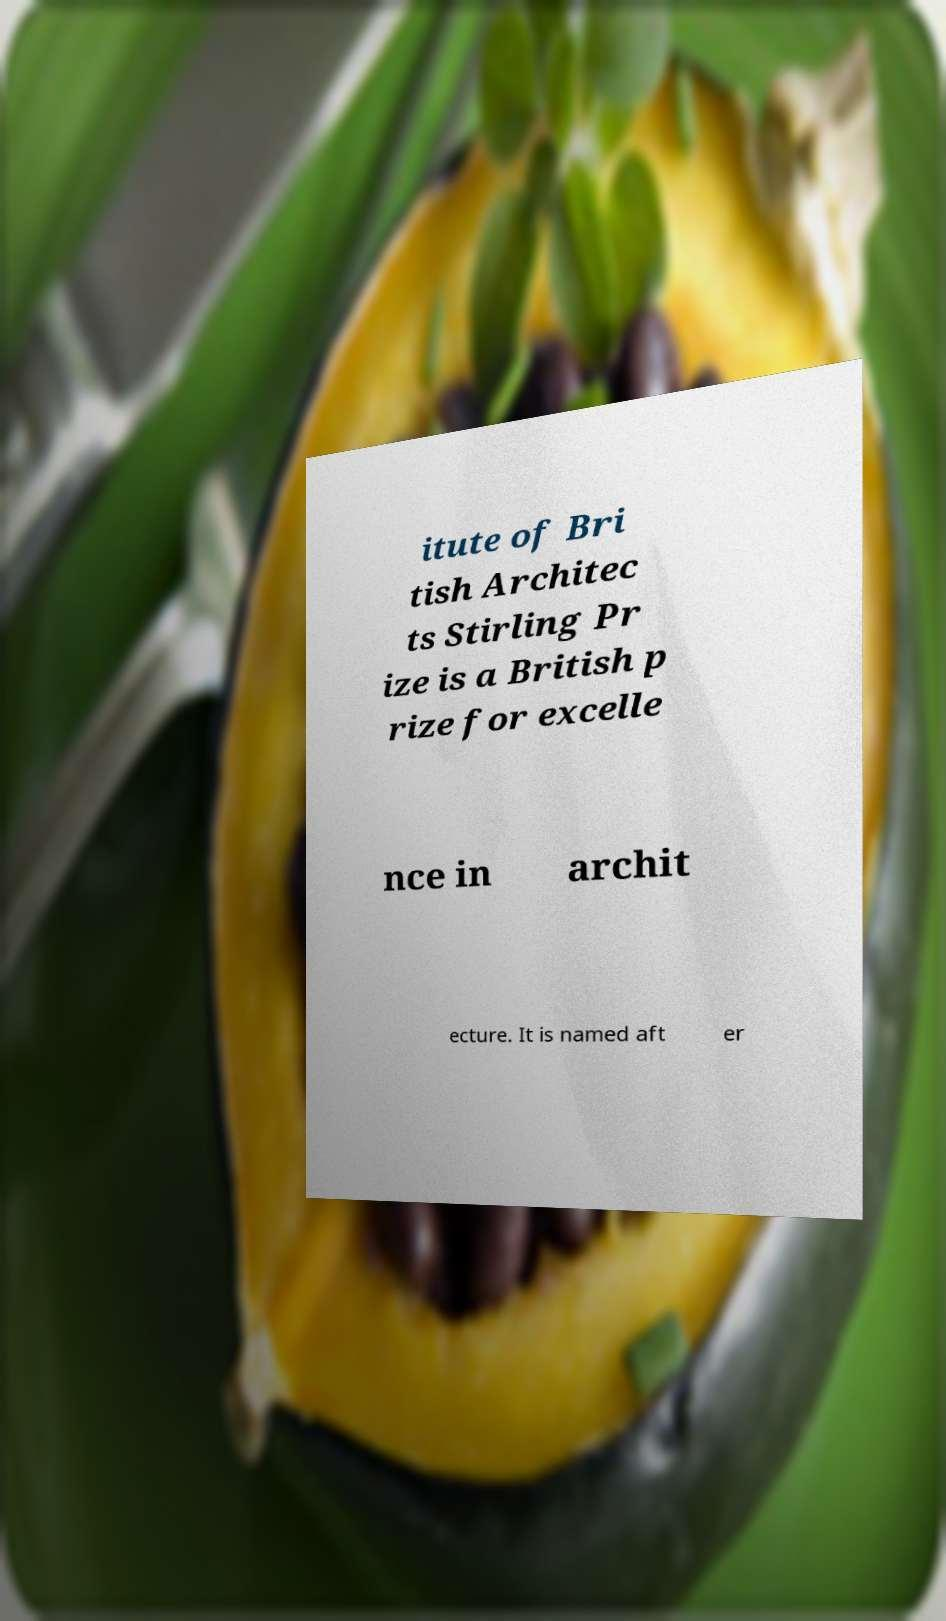Could you assist in decoding the text presented in this image and type it out clearly? itute of Bri tish Architec ts Stirling Pr ize is a British p rize for excelle nce in archit ecture. It is named aft er 